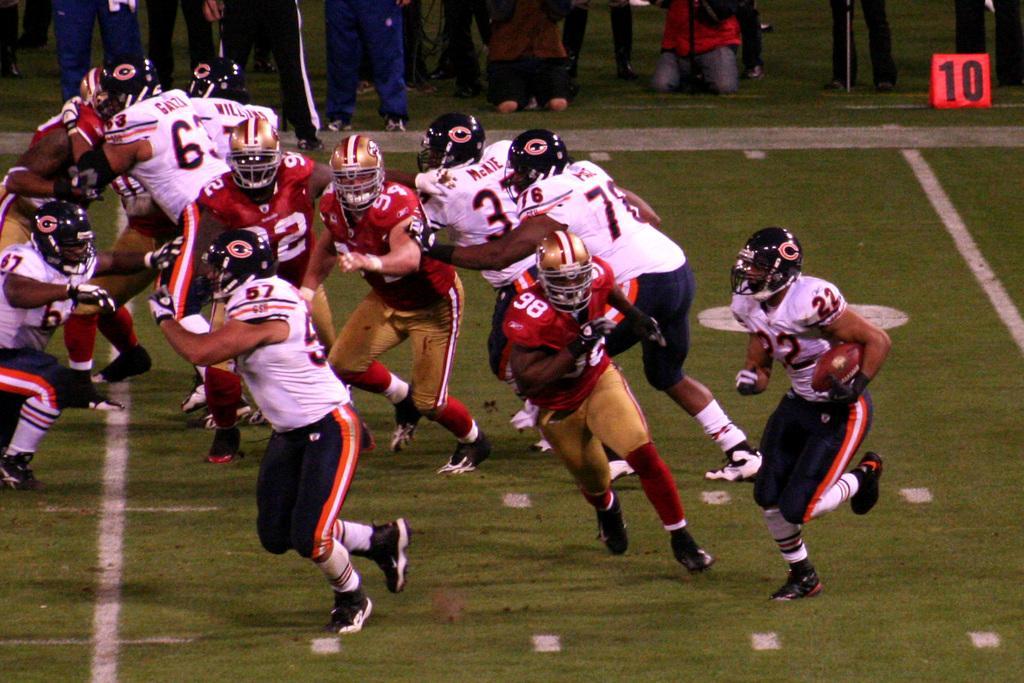Can you describe this image briefly? In this picture, we see many people in red T-shirts and white T-shirts are playing football. Behind them, we see people standing on the ground. This picture is clicked in the football field. 